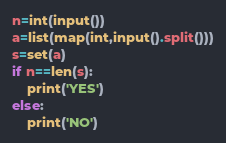<code> <loc_0><loc_0><loc_500><loc_500><_Python_>n=int(input())
a=list(map(int,input().split()))
s=set(a)
if n==len(s):
    print('YES')
else:
    print('NO')</code> 